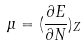<formula> <loc_0><loc_0><loc_500><loc_500>\mu = ( \frac { \partial E } { \partial N } ) _ { Z }</formula> 